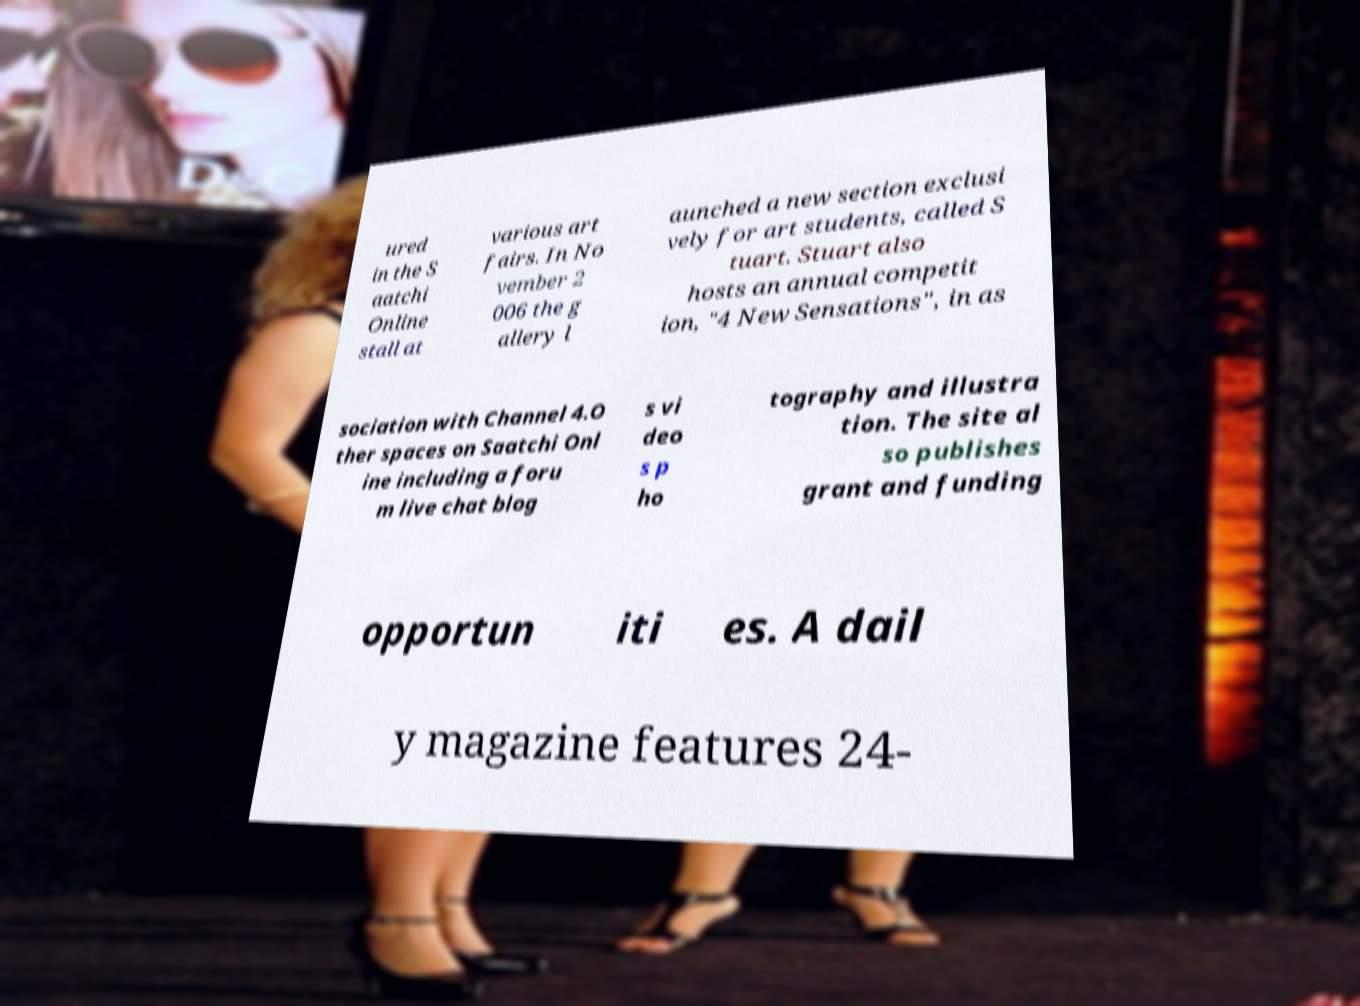Please identify and transcribe the text found in this image. ured in the S aatchi Online stall at various art fairs. In No vember 2 006 the g allery l aunched a new section exclusi vely for art students, called S tuart. Stuart also hosts an annual competit ion, "4 New Sensations", in as sociation with Channel 4.O ther spaces on Saatchi Onl ine including a foru m live chat blog s vi deo s p ho tography and illustra tion. The site al so publishes grant and funding opportun iti es. A dail y magazine features 24- 